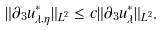Convert formula to latex. <formula><loc_0><loc_0><loc_500><loc_500>\| \partial _ { 3 } u ^ { * } _ { \lambda , \eta } \| _ { L ^ { 2 } } \leq c \| \partial _ { 3 } u ^ { * } _ { \lambda } \| _ { L ^ { 2 } } .</formula> 